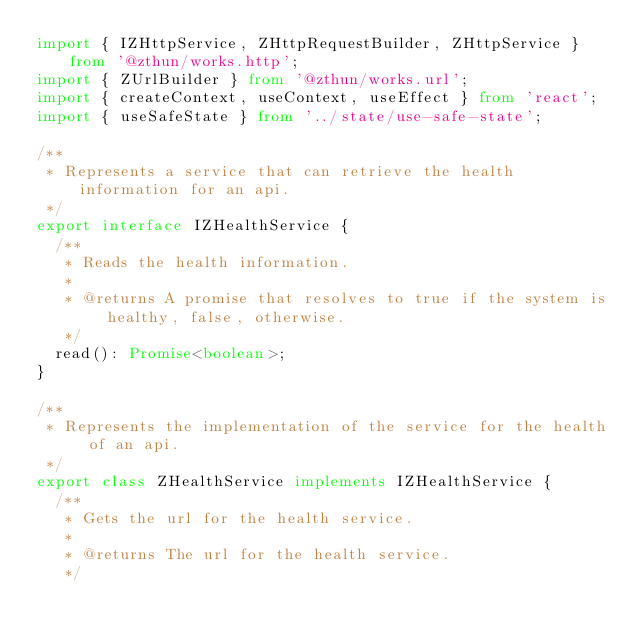<code> <loc_0><loc_0><loc_500><loc_500><_TypeScript_>import { IZHttpService, ZHttpRequestBuilder, ZHttpService } from '@zthun/works.http';
import { ZUrlBuilder } from '@zthun/works.url';
import { createContext, useContext, useEffect } from 'react';
import { useSafeState } from '../state/use-safe-state';

/**
 * Represents a service that can retrieve the health information for an api.
 */
export interface IZHealthService {
  /**
   * Reads the health information.
   *
   * @returns A promise that resolves to true if the system is healthy, false, otherwise.
   */
  read(): Promise<boolean>;
}

/**
 * Represents the implementation of the service for the health of an api.
 */
export class ZHealthService implements IZHealthService {
  /**
   * Gets the url for the health service.
   *
   * @returns The url for the health service.
   */</code> 